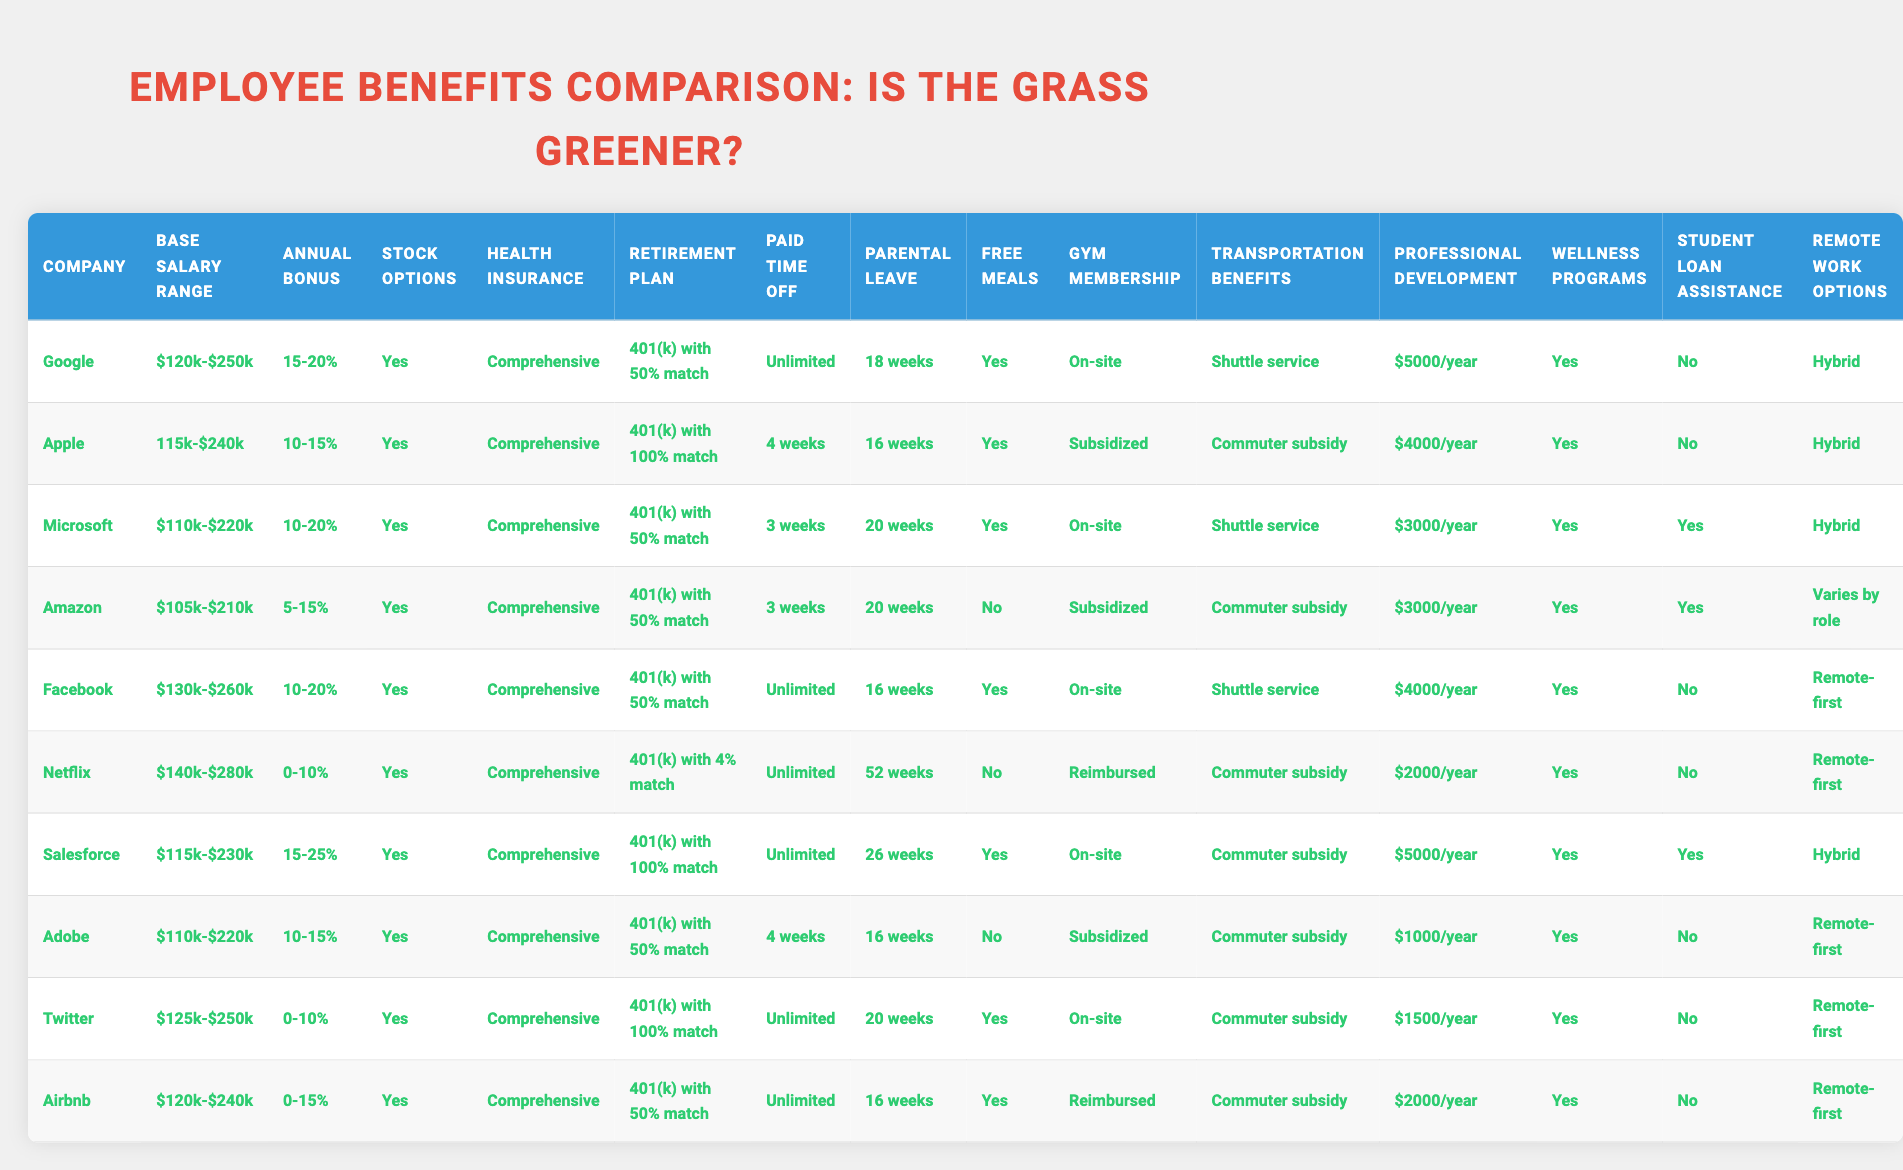What is the base salary range for Apple? The base salary range for Apple is listed directly in the table under the "Base Salary Range" column. It shows "$115k-$240k".
Answer: $115k-$240k Which company offers the highest annual bonus? To determine the highest annual bonus, I compare the values in the "Annual Bonus" column. The maximum value is "15-25%" from Salesforce.
Answer: Salesforce (15-25%) Does Netflix provide free meals? By checking the "Free Meals" column for Netflix, it states "No." This means Netflix does not provide free meals.
Answer: No What is the average parental leave duration for companies offering "Unlimited" paid time off? I first identify the companies with unlimited paid time off, which are Google, Facebook, Netflix, Airbnb, and Twitter. Their parental leave durations are 18 weeks, 16 weeks, 52 weeks, 20 weeks, and 16 weeks respectively. The total is 18 + 16 + 52 + 20 + 16 = 122 weeks. There are 5 companies, so the average is 122/5 = 24.4 weeks.
Answer: 24.4 weeks Which company has the lowest retirement plan match percentage? I must look at the "Retirement Plan" column. The lowest match percentage is 4% from Netflix, as it’s less than all other values listed.
Answer: Netflix (4%) Is there a company that offers student loan assistance? I check the "Student Loan Assistance" column for each company. Only Microsoft and Salesforce have a "Yes" listed.
Answer: Yes (Microsoft and Salesforce) What is the stock options offering for Adobe? The stock options status is noted in the "Stock Options" column. For Adobe, the entry states "Yes."
Answer: Yes Which company provides the most professional development funding per year? Evaluating the "Professional Development" column, Salesforce offers the highest at "$5000/year."
Answer: Salesforce ($5000/year) How many companies provide on-site gym memberships? Counting the entries in the "Gym Membership" column, I see that 6 companies offer "On-site" memberships: Google, Microsoft, Facebook, Salesforce, Twitter, and Airbnb. So, the total number is 6.
Answer: 6 companies Which company has the highest base salary range and what is that range? To answer this, I compare the ranges listed in the "Base Salary Range" column. The highest range is $140k-$280k from Netflix, which I determined by identifying the maximum values.
Answer: Netflix ($140k-$280k) 